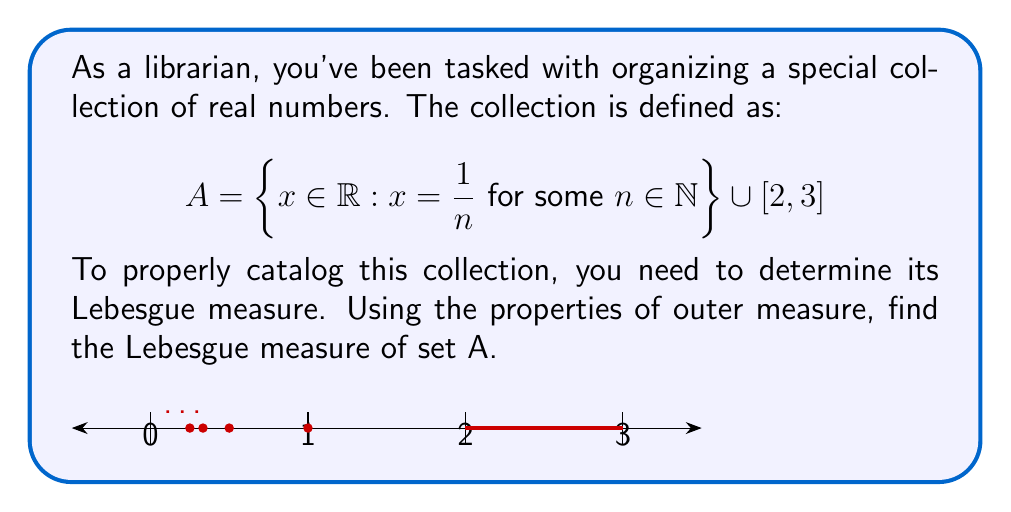Show me your answer to this math problem. Let's approach this step-by-step:

1) The set A is the union of two subsets:
   $$A_1 = \left\{\frac{1}{n} : n \in \mathbb{N}\right\}$$
   $$A_2 = [2,3]$$

2) For $A_2$, it's straightforward. The Lebesgue measure of an interval is its length:
   $$m(A_2) = 3 - 2 = 1$$

3) For $A_1$, we need to be more careful. This is a countable set of points. In Lebesgue measure theory, any countable set has measure zero. Therefore:
   $$m(A_1) = 0$$

4) Now, we can use the countable additivity property of Lebesgue measure:
   $$m(A) = m(A_1 \cup A_2) = m(A_1) + m(A_2)$$

5) Substituting the values we found:
   $$m(A) = 0 + 1 = 1$$

Therefore, the Lebesgue measure of set A is 1.

Note: We didn't explicitly use outer measure properties here because the set A can be directly measured using basic Lebesgue measure properties. However, it's worth noting that for any set E, the Lebesgue measure m(E) is defined as the infimum of the outer measures of all open sets containing E. In this case, the outer measure would give the same result as our direct calculation.
Answer: 1 